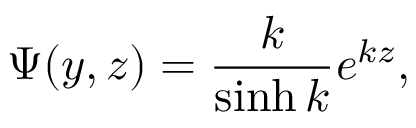Convert formula to latex. <formula><loc_0><loc_0><loc_500><loc_500>\Psi ( y , z ) = { \frac { k } { \sinh k } } e ^ { k z } ,</formula> 